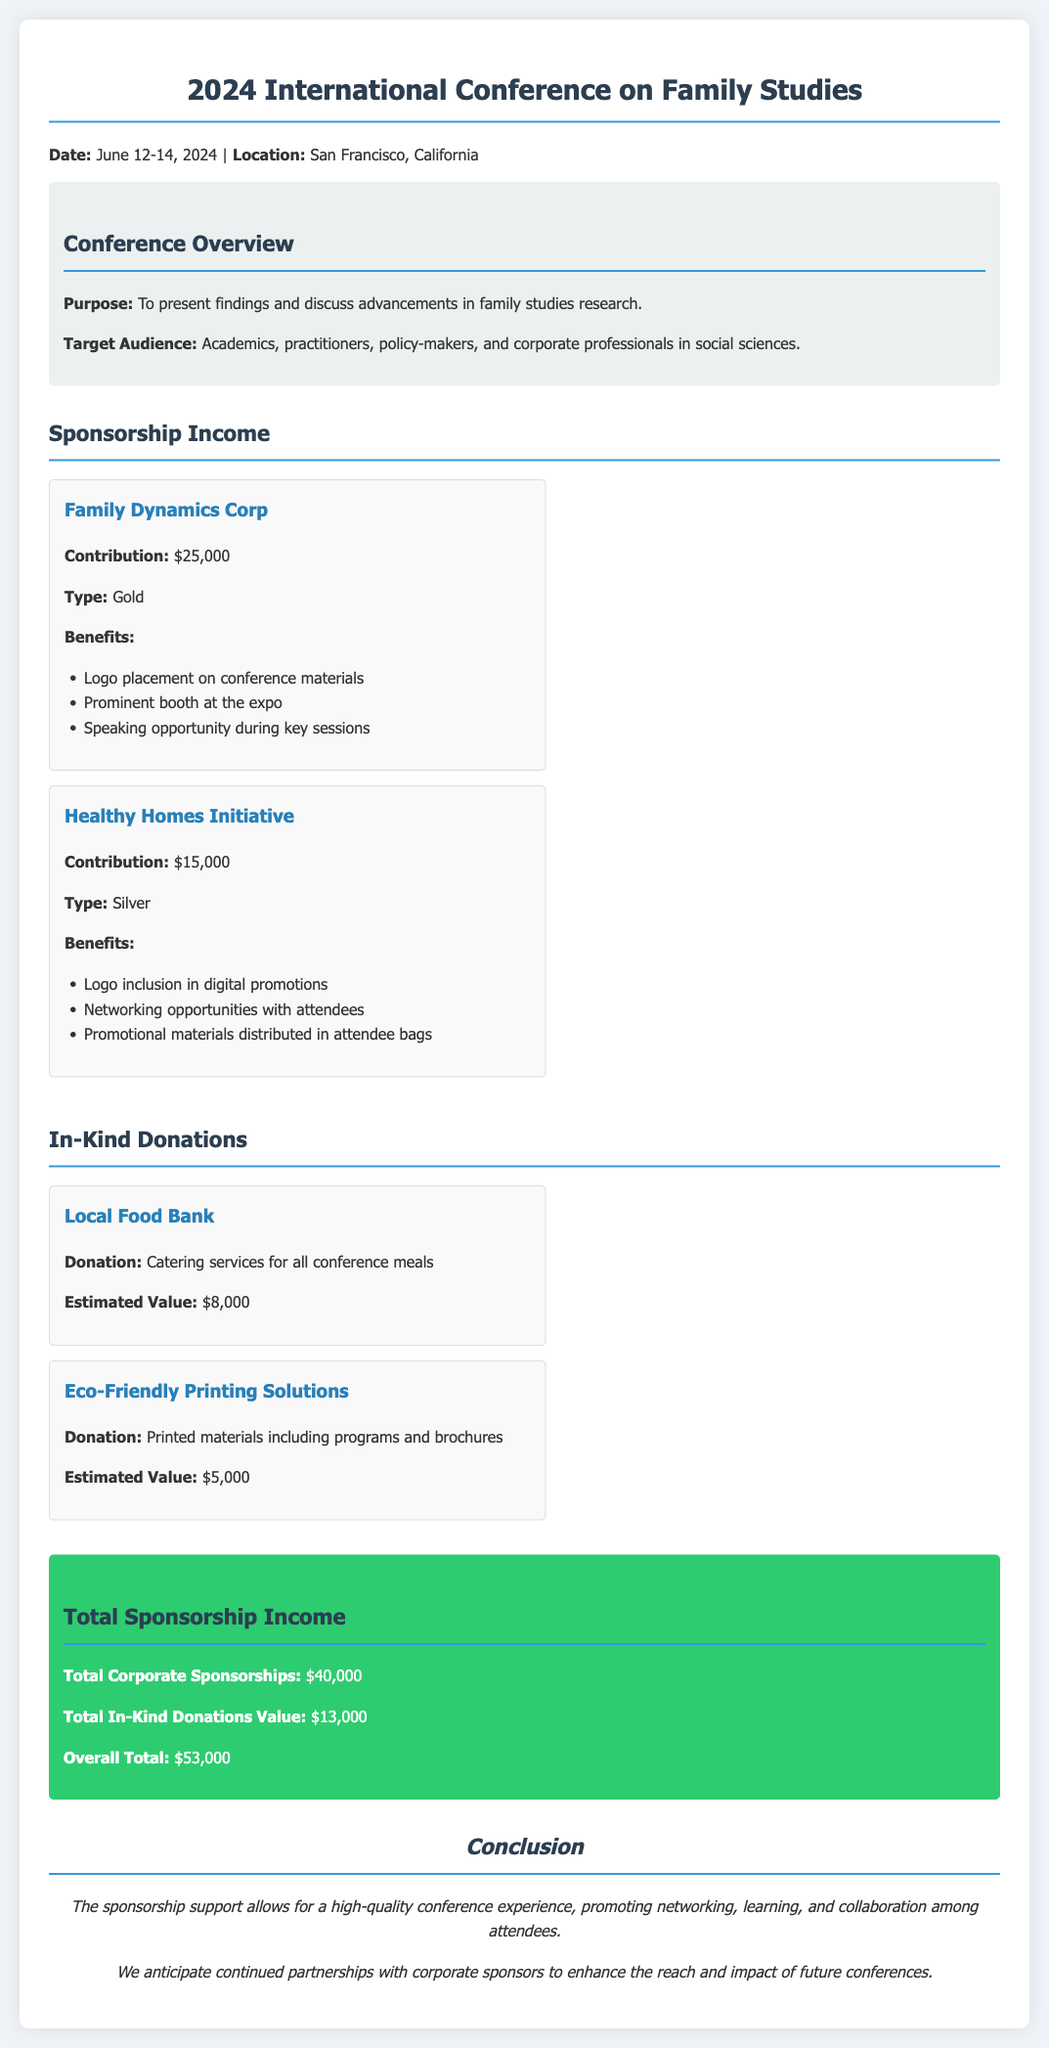what is the date of the conference? The date of the conference is stated in the document as June 12-14, 2024.
Answer: June 12-14, 2024 who contributed $25,000? This information is found under the sponsorship income section, where Family Dynamics Corp is listed with that contribution.
Answer: Family Dynamics Corp what is the estimated value of the catering services donation? The document specifies the estimated value of the Local Food Bank's catering services donation as $8,000.
Answer: $8,000 what benefits does the Silver sponsor receive? The benefits of the Silver sponsor, Healthy Homes Initiative, are listed in the sponsorship income section, making it a reasoning question that compiles the details provided.
Answer: Logo inclusion in digital promotions, Networking opportunities with attendees, Promotional materials distributed in attendee bags what is the overall total sponsorship income? The overall total is calculated from the total corporate sponsorships and total in-kind donations listed.
Answer: $53,000 what type of document is this? The structure and content indicate it is a financial report related to sponsorships for a conference.
Answer: Sponsorship Revenue Report 